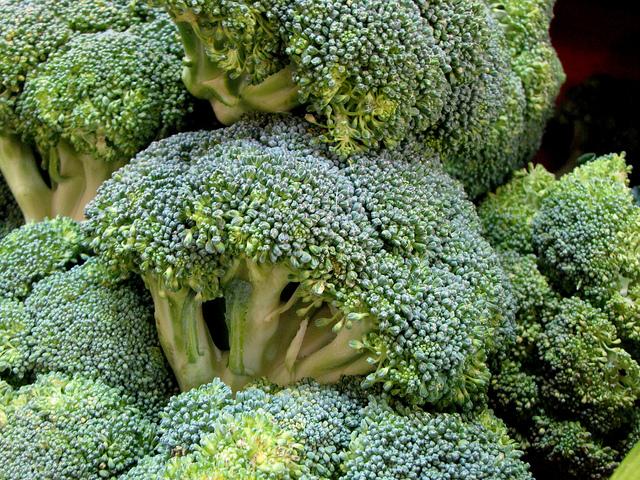How many stalks can you see?
Write a very short answer. 5. What type of vegetable is this?
Write a very short answer. Broccoli. What color is the broccoli?
Answer briefly. Green. 